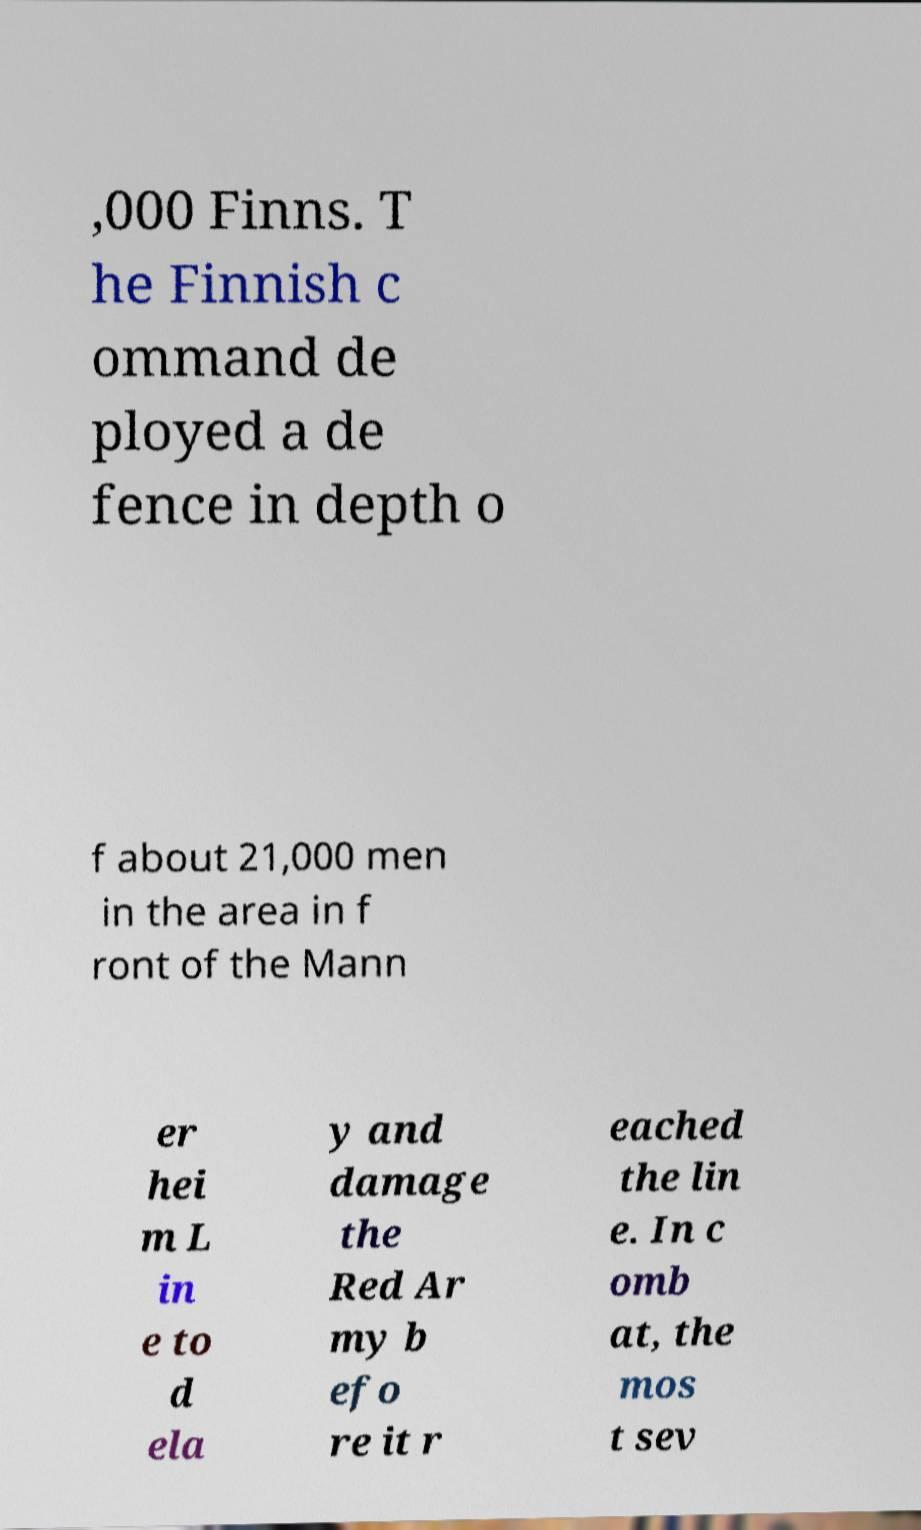Could you assist in decoding the text presented in this image and type it out clearly? ,000 Finns. T he Finnish c ommand de ployed a de fence in depth o f about 21,000 men in the area in f ront of the Mann er hei m L in e to d ela y and damage the Red Ar my b efo re it r eached the lin e. In c omb at, the mos t sev 